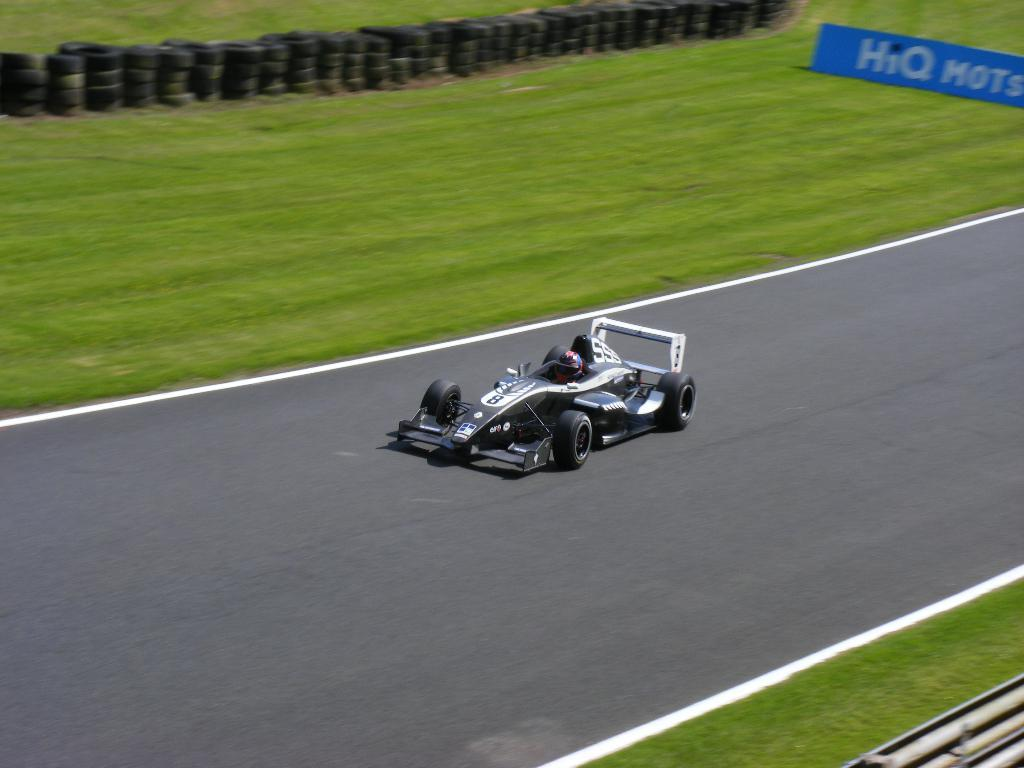What is the main feature of the image? There is a road in the image. What type of vehicle can be seen on the road? There is a black-colored vehicle on the road. What can be seen growing alongside the road? There is grass visible in the image. What color is the board in the image? There is a blue board in the image. How many tires are visible in the image? There are multiple tires visible in the image. What is written on the blue board? There is text written on the blue board. Can you see the canvas of the painting in the image? There is no painting or canvas present in the image. What type of parent is depicted in the image? There is no parent or any human figure present in the image. 